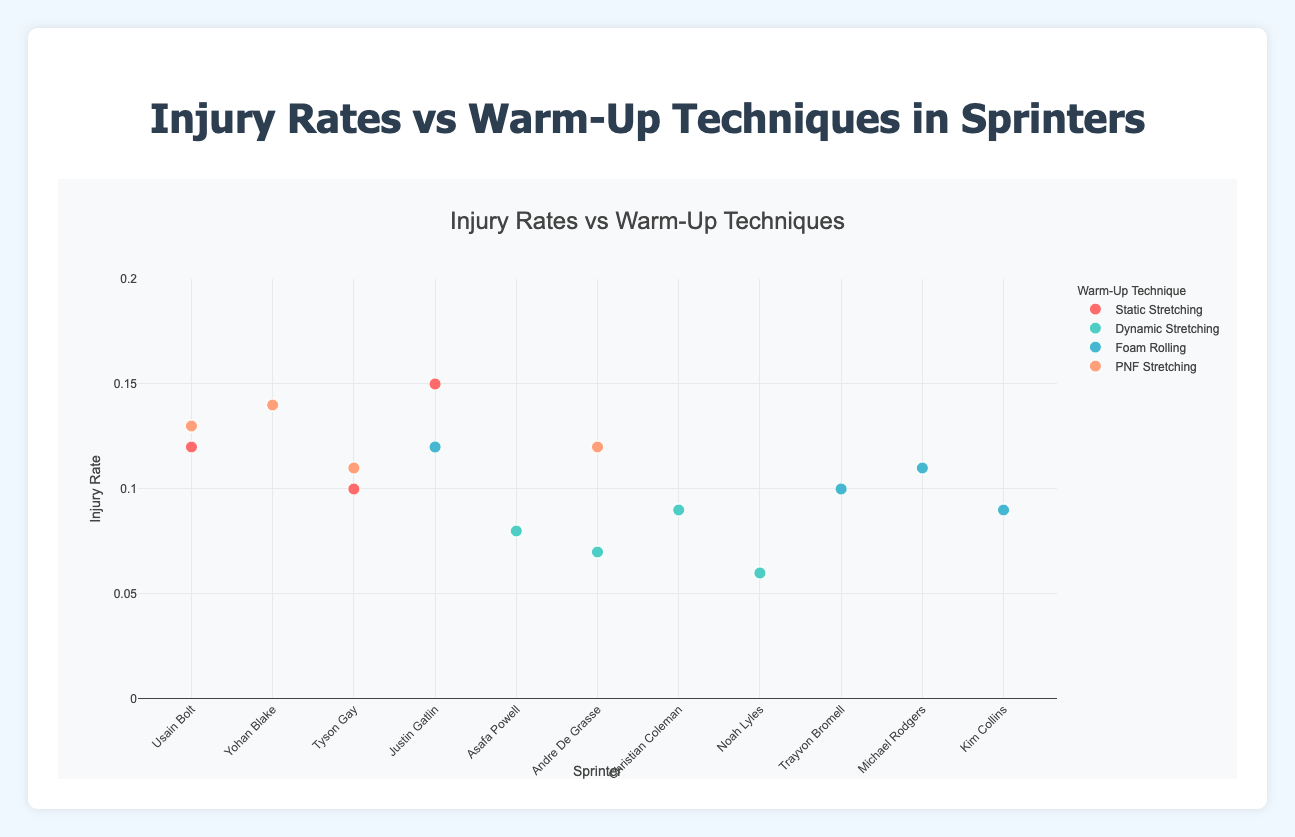Which warm-up technique has the highest average injury rate? Sum up the injury rates for each warm-up technique and divide by the number of sprinters using that technique. Static Stretching: (0.12 + 0.14 + 0.10 + 0.15) / 4 = 0.1275, Dynamic Stretching: (0.08 + 0.07 + 0.09 + 0.06) / 4 = 0.075, Foam Rolling: (0.10 + 0.11 + 0.09 + 0.12) / 4 = 0.105, PNF Stretching: (0.13 + 0.14 + 0.11 + 0.12) / 4 = 0.125
Answer: Static Stretching Which sprinter has the lowest injury rate and with which warm-up technique? Observe the y-values on the scatter plot and find the smallest injury rate. The lowest injury rate is 0.06 associated with Noah Lyles using Dynamic Stretching.
Answer: Noah Lyles with Dynamic Stretching How many sprinters used the Foam Rolling warm-up technique? Count the number of data points in the scatter plot associated with Foam Rolling. There are four sprinters: Trayvon Bromell, Michael Rodgers, Kim Collins, and Justin Gatlin.
Answer: 4 Between Dynamic and Static Stretching, which has a lower maximum injury rate and what is that rate? Compare the maximum y-values for Dynamic Stretching and Static Stretching. Dynamic Stretching's highest rate is 0.09, while Static Stretching's is 0.15.
Answer: Dynamic Stretching with 0.09 Which warm-up technique does Justin Gatlin use and what are his injury rates? Justin Gatlin appears twice, once with Static Stretching at 0.15 and once with Foam Rolling at 0.12.
Answer: Static Stretching (0.15) and Foam Rolling (0.12) Is there any sprinter who uses more than one warm-up technique? If so, who and which techniques? Identify sprinters appearing more than once with different warm-up techniques. Justin Gatlin uses both Static Stretching and Foam Rolling.
Answer: Justin Gatlin with Static Stretching and Foam Rolling What is the range of injury rates for Dynamic Stretching? Identify the minimum and maximum injury rates for Dynamic Stretching. The minimum is 0.06 and the maximum is 0.09, so the range is 0.09 - 0.06.
Answer: 0.03 Which warm-up technique has the most consistent injury rates (smallest range) and what is that range? Calculate the range for each technique. Static Stretching: 0.15 - 0.10 = 0.05, Dynamic Stretching: 0.09 - 0.06 = 0.03, Foam Rolling: 0.12 - 0.09 = 0.03, PNF Stretching: 0.14 - 0.11 = 0.03. Dynamic Stretching, Foam Rolling, and PNF Stretching have the smallest range of 0.03.
Answer: Dynamic Stretching, Foam Rolling, and PNF Stretching (0.03) Which warm-up technique has the widest spread of injury rates? Calculate the range for each technique. Static Stretching has the widest spread of 0.05.
Answer: Static Stretching Who are the sprinters that achieved injury rates below 0.10, and which warm-up techniques did they use? Usain Bolt (Static Stretching, 0.12), Yohan Blake (Static Stretching, 0.14), Tyson Gay (Static Stretching, 0.10), Justin Gatlin (Static Stretching, 0.15), Asafa Powell (Dynamic Stretching, 0.08), Andre De Grasse (Dynamic Stretching, 0.07), Christian Coleman (Dynamic Stretching, 0.09), Noah Lyles (Dynamic Stretching, 0.06), Trayvon Bromell (Foam Rolling, 0.10), Michael Rodgers (Foam Rolling, 0.11), Kim Collins (Foam Rolling, 0.09), Justin Gatlin (Foam Rolling, 0.12), Usain Bolt (PNF Stretching, 0.13), Yohan Blake (PNF Stretching, 0.14), Tyson Gay (PNF Stretching, 0.11), Andre De Grasse (PNF Stretching, 0.12). The sprinters with injury rates below 0.10 are Asafa Powell (0.08, Dynamic Stretching), Andre De Grasse (0.07, Dynamic Stretching), Christian Coleman (0.09, Dynamic Stretching), Noah Lyles (0.06, Dynamic Stretching), and Kim Collins (0.09, Foam Rolling).
Answer: Asafa Powell, Andre De Grasse, Christian Coleman, Noah Lyles, and Kim Collins 